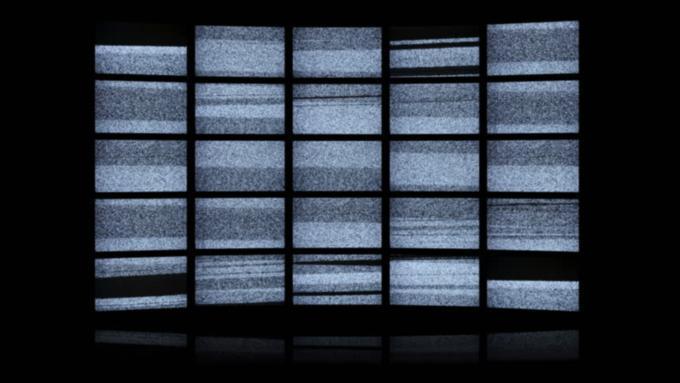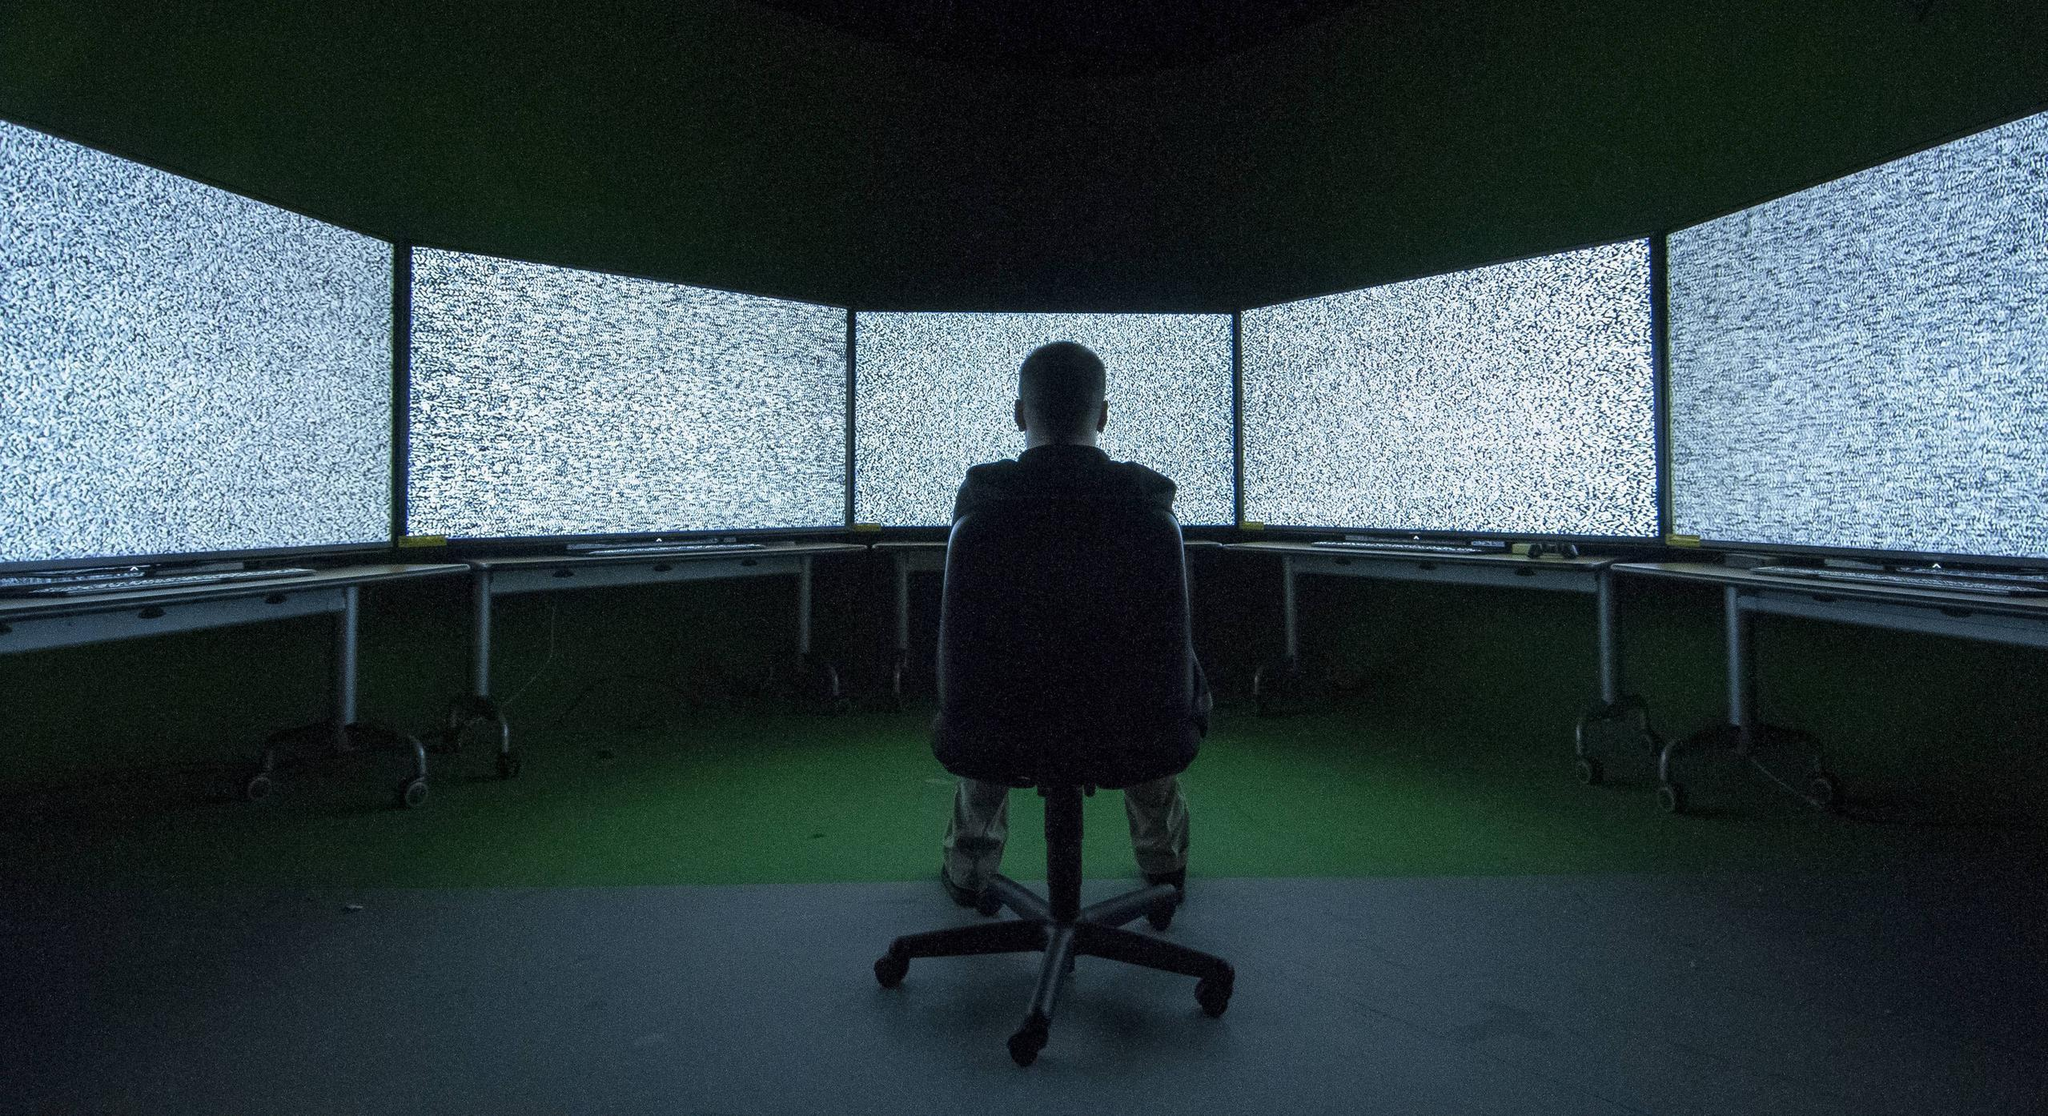The first image is the image on the left, the second image is the image on the right. For the images displayed, is the sentence "multiple tv's are mounted to a single wall" factually correct? Answer yes or no. Yes. The first image is the image on the left, the second image is the image on the right. Given the left and right images, does the statement "There are multiple screens in the right image." hold true? Answer yes or no. Yes. 